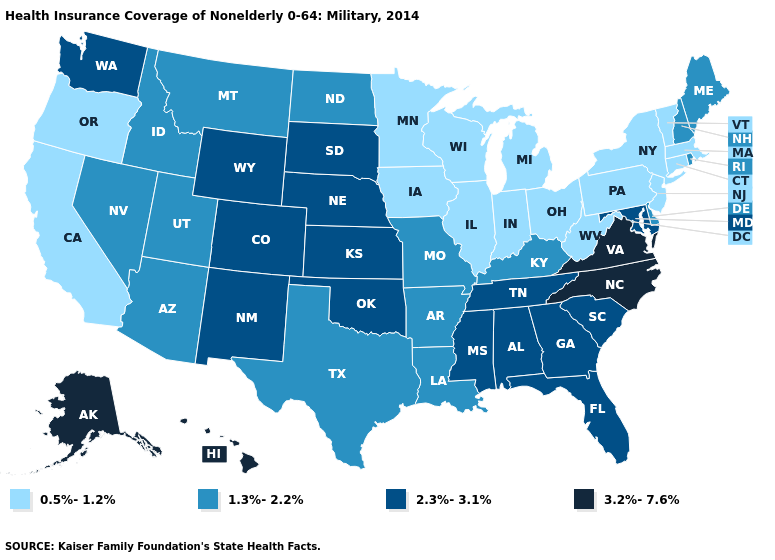What is the highest value in states that border Florida?
Concise answer only. 2.3%-3.1%. What is the lowest value in the MidWest?
Give a very brief answer. 0.5%-1.2%. What is the lowest value in states that border Kansas?
Answer briefly. 1.3%-2.2%. What is the highest value in the West ?
Give a very brief answer. 3.2%-7.6%. Name the states that have a value in the range 3.2%-7.6%?
Short answer required. Alaska, Hawaii, North Carolina, Virginia. Which states have the lowest value in the South?
Answer briefly. West Virginia. How many symbols are there in the legend?
Write a very short answer. 4. Does North Carolina have the highest value in the USA?
Concise answer only. Yes. Name the states that have a value in the range 3.2%-7.6%?
Give a very brief answer. Alaska, Hawaii, North Carolina, Virginia. What is the value of Indiana?
Quick response, please. 0.5%-1.2%. Does Alabama have the lowest value in the USA?
Short answer required. No. What is the lowest value in the USA?
Be succinct. 0.5%-1.2%. Which states hav the highest value in the South?
Write a very short answer. North Carolina, Virginia. What is the value of New York?
Short answer required. 0.5%-1.2%. Does the map have missing data?
Keep it brief. No. 